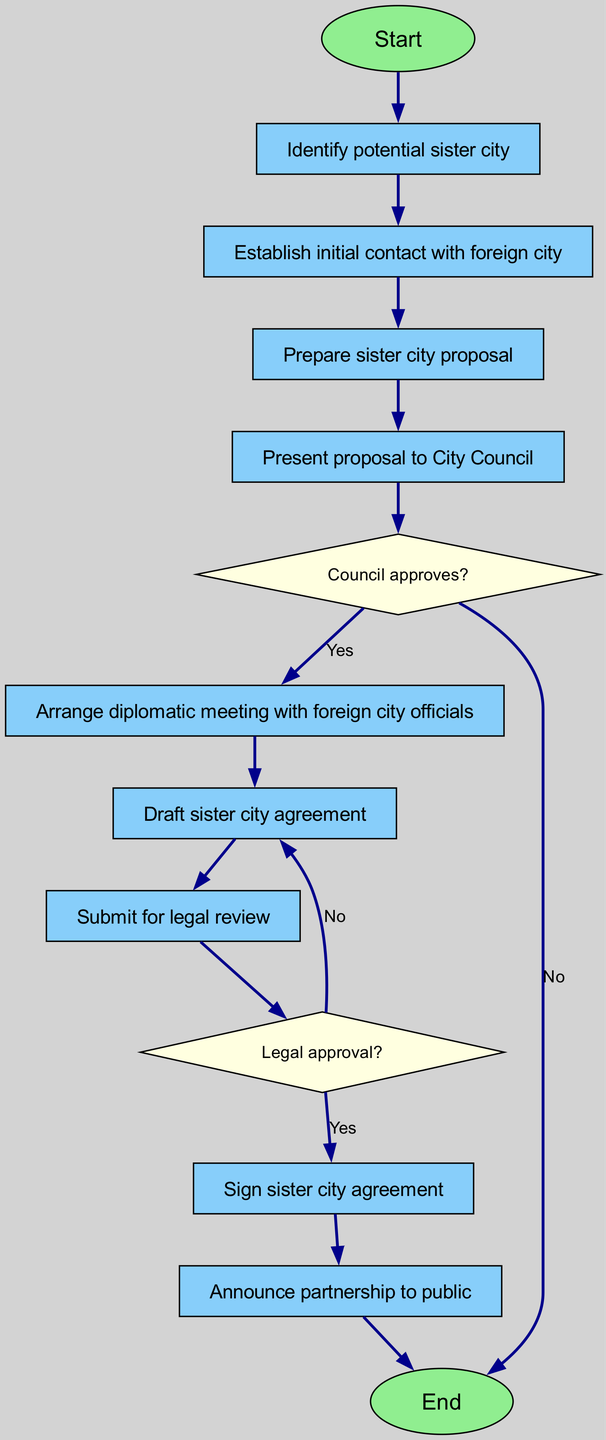What is the first step in the process? The first step is indicated by the start node, which is labeled "Start." This node initiates the process for approving an international sister city agreement.
Answer: Start How many decision nodes are there in the diagram? There are two decision nodes in the diagram: "Council approves?" and "Legal approval?" Counting them gives a total of two decision nodes.
Answer: 2 What happens if the City Council does not approve the proposal? If the City Council does not approve, the flow proceeds to the end node as indicated by the edge from the "decision_1" node to the "end" node labeled "No."
Answer: End Which node follows the "Draft sister city agreement" node? The node that follows "Draft sister city agreement" is "Submit for legal review," as shown by the direct connection between these two nodes in the progression of the diagram.
Answer: Submit for legal review What is the outcome if the legal review does not yield approval? If the legal review does not yield approval, the flow returns to "Draft sister city agreement," following the edge labeled "No," which indicates that the process must revisit this node.
Answer: Draft sister city agreement How is the partnership announced to the public? The partnership is announced to the public through the "Announce partnership to public" node, which is the final step in the process before the flow reaches the end.
Answer: Announce partnership to public What is the last step before reaching the end of the process? The last step before reaching the end of the process is "Announce partnership to public," which is the final action taken in the flowchart.
Answer: Announce partnership to public Which nodes are directly connected to "Arrange diplomatic meeting with foreign city officials"? The node "Arrange diplomatic meeting with foreign city officials" is directly connected to the previous node "Establish initial contact with foreign city" and the subsequent node "Draft sister city agreement." Thus, these two nodes are directly adjacent.
Answer: Prepare sister city proposal, Draft sister city agreement What happens after the "Sign sister city agreement" node? After the "Sign sister city agreement" node, the process flows to the "Announce partnership to public" node, indicating the next action to take after signing.
Answer: Announce partnership to public 